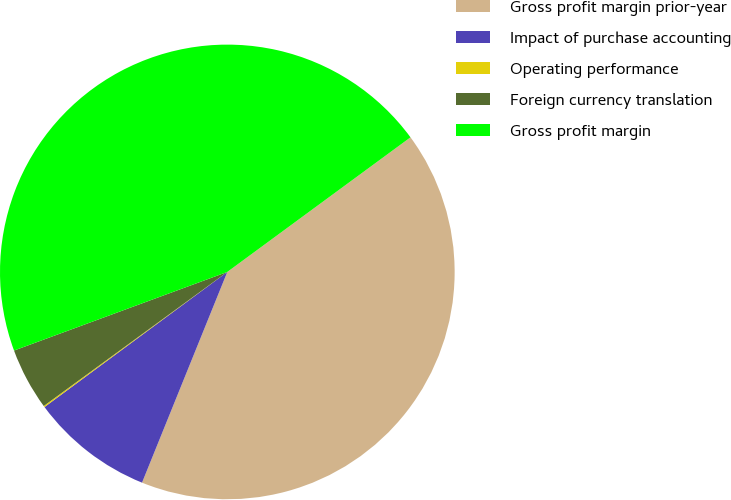Convert chart to OTSL. <chart><loc_0><loc_0><loc_500><loc_500><pie_chart><fcel>Gross profit margin prior-year<fcel>Impact of purchase accounting<fcel>Operating performance<fcel>Foreign currency translation<fcel>Gross profit margin<nl><fcel>41.21%<fcel>8.75%<fcel>0.09%<fcel>4.42%<fcel>45.54%<nl></chart> 